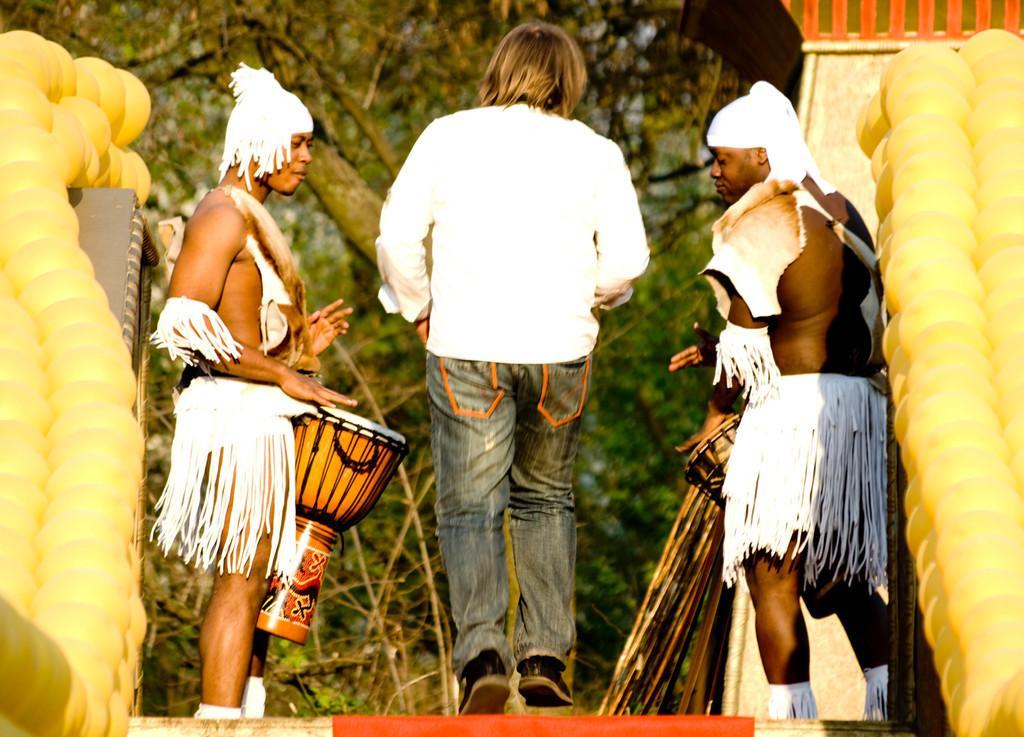In one or two sentences, can you explain what this image depicts? In the image we can see there are three men who are standing and the man in between is wearing white shirt and jeans and either sides of the man there are two men who are holding a drum. Beside them there are balloons which are in a shape of corn. In Front of them there are lot of trees. 